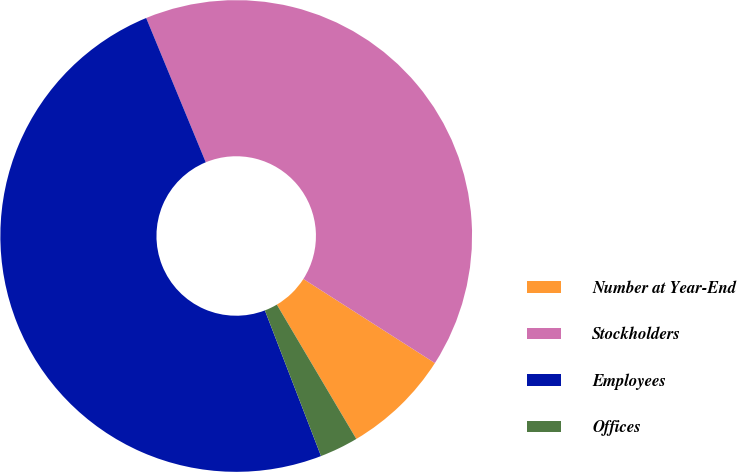<chart> <loc_0><loc_0><loc_500><loc_500><pie_chart><fcel>Number at Year-End<fcel>Stockholders<fcel>Employees<fcel>Offices<nl><fcel>7.44%<fcel>40.29%<fcel>49.62%<fcel>2.65%<nl></chart> 